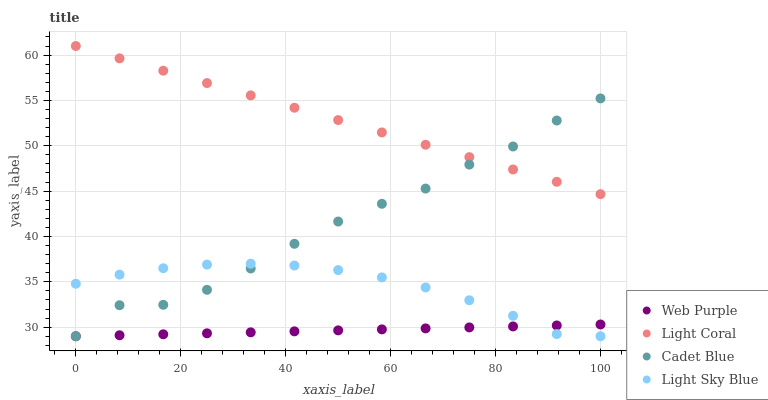Does Web Purple have the minimum area under the curve?
Answer yes or no. Yes. Does Light Coral have the maximum area under the curve?
Answer yes or no. Yes. Does Cadet Blue have the minimum area under the curve?
Answer yes or no. No. Does Cadet Blue have the maximum area under the curve?
Answer yes or no. No. Is Light Coral the smoothest?
Answer yes or no. Yes. Is Cadet Blue the roughest?
Answer yes or no. Yes. Is Web Purple the smoothest?
Answer yes or no. No. Is Web Purple the roughest?
Answer yes or no. No. Does Web Purple have the lowest value?
Answer yes or no. Yes. Does Light Coral have the highest value?
Answer yes or no. Yes. Does Cadet Blue have the highest value?
Answer yes or no. No. Is Light Sky Blue less than Light Coral?
Answer yes or no. Yes. Is Light Coral greater than Light Sky Blue?
Answer yes or no. Yes. Does Cadet Blue intersect Light Sky Blue?
Answer yes or no. Yes. Is Cadet Blue less than Light Sky Blue?
Answer yes or no. No. Is Cadet Blue greater than Light Sky Blue?
Answer yes or no. No. Does Light Sky Blue intersect Light Coral?
Answer yes or no. No. 